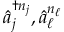Convert formula to latex. <formula><loc_0><loc_0><loc_500><loc_500>\hat { a } _ { j } ^ { \dag n _ { j } } , \hat { a } _ { \ell } ^ { n _ { \ell } }</formula> 